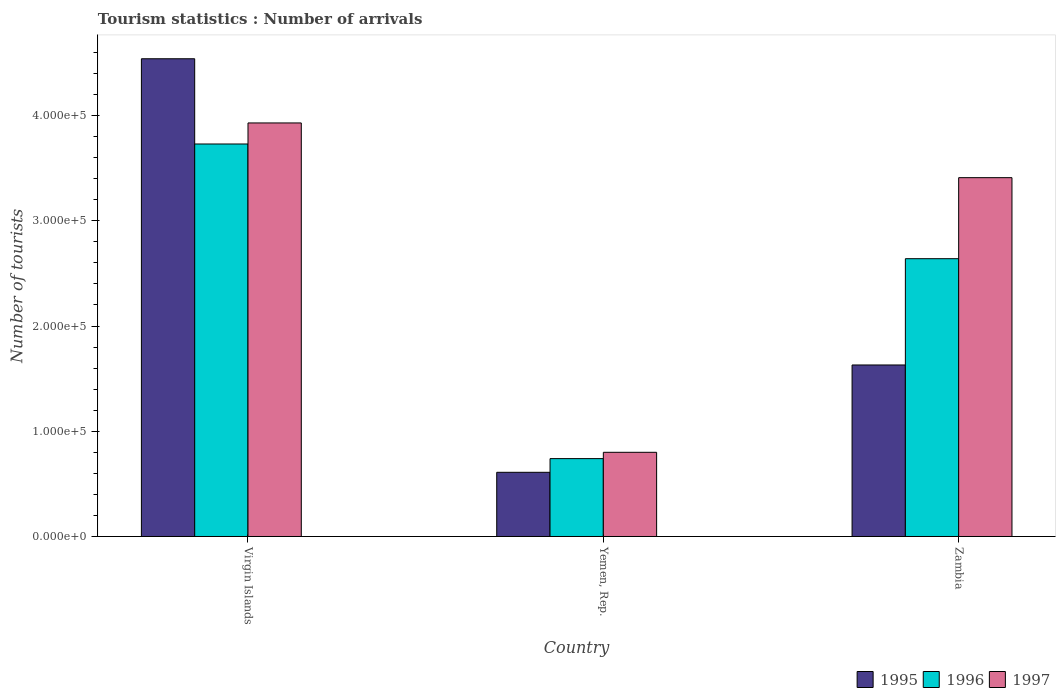How many groups of bars are there?
Offer a very short reply. 3. Are the number of bars per tick equal to the number of legend labels?
Provide a succinct answer. Yes. How many bars are there on the 3rd tick from the left?
Provide a short and direct response. 3. How many bars are there on the 3rd tick from the right?
Offer a very short reply. 3. What is the label of the 2nd group of bars from the left?
Your response must be concise. Yemen, Rep. What is the number of tourist arrivals in 1995 in Virgin Islands?
Ensure brevity in your answer.  4.54e+05. Across all countries, what is the maximum number of tourist arrivals in 1997?
Provide a short and direct response. 3.93e+05. Across all countries, what is the minimum number of tourist arrivals in 1995?
Your answer should be very brief. 6.10e+04. In which country was the number of tourist arrivals in 1996 maximum?
Your answer should be very brief. Virgin Islands. In which country was the number of tourist arrivals in 1995 minimum?
Provide a succinct answer. Yemen, Rep. What is the total number of tourist arrivals in 1995 in the graph?
Make the answer very short. 6.78e+05. What is the difference between the number of tourist arrivals in 1996 in Yemen, Rep. and that in Zambia?
Your answer should be very brief. -1.90e+05. What is the average number of tourist arrivals in 1996 per country?
Make the answer very short. 2.37e+05. What is the difference between the number of tourist arrivals of/in 1995 and number of tourist arrivals of/in 1996 in Yemen, Rep.?
Offer a very short reply. -1.30e+04. In how many countries, is the number of tourist arrivals in 1996 greater than 200000?
Your answer should be compact. 2. What is the ratio of the number of tourist arrivals in 1996 in Yemen, Rep. to that in Zambia?
Offer a very short reply. 0.28. What is the difference between the highest and the second highest number of tourist arrivals in 1996?
Ensure brevity in your answer.  2.99e+05. What is the difference between the highest and the lowest number of tourist arrivals in 1997?
Provide a succinct answer. 3.13e+05. Is the sum of the number of tourist arrivals in 1995 in Yemen, Rep. and Zambia greater than the maximum number of tourist arrivals in 1996 across all countries?
Provide a succinct answer. No. What does the 1st bar from the left in Yemen, Rep. represents?
Your answer should be compact. 1995. How many bars are there?
Provide a short and direct response. 9. What is the difference between two consecutive major ticks on the Y-axis?
Give a very brief answer. 1.00e+05. Where does the legend appear in the graph?
Your answer should be compact. Bottom right. How many legend labels are there?
Offer a terse response. 3. How are the legend labels stacked?
Your answer should be very brief. Horizontal. What is the title of the graph?
Your response must be concise. Tourism statistics : Number of arrivals. Does "1981" appear as one of the legend labels in the graph?
Provide a succinct answer. No. What is the label or title of the X-axis?
Provide a succinct answer. Country. What is the label or title of the Y-axis?
Keep it short and to the point. Number of tourists. What is the Number of tourists of 1995 in Virgin Islands?
Provide a succinct answer. 4.54e+05. What is the Number of tourists of 1996 in Virgin Islands?
Make the answer very short. 3.73e+05. What is the Number of tourists of 1997 in Virgin Islands?
Provide a short and direct response. 3.93e+05. What is the Number of tourists in 1995 in Yemen, Rep.?
Provide a short and direct response. 6.10e+04. What is the Number of tourists in 1996 in Yemen, Rep.?
Offer a terse response. 7.40e+04. What is the Number of tourists in 1995 in Zambia?
Make the answer very short. 1.63e+05. What is the Number of tourists in 1996 in Zambia?
Give a very brief answer. 2.64e+05. What is the Number of tourists of 1997 in Zambia?
Make the answer very short. 3.41e+05. Across all countries, what is the maximum Number of tourists in 1995?
Make the answer very short. 4.54e+05. Across all countries, what is the maximum Number of tourists of 1996?
Make the answer very short. 3.73e+05. Across all countries, what is the maximum Number of tourists of 1997?
Give a very brief answer. 3.93e+05. Across all countries, what is the minimum Number of tourists of 1995?
Offer a very short reply. 6.10e+04. Across all countries, what is the minimum Number of tourists of 1996?
Make the answer very short. 7.40e+04. Across all countries, what is the minimum Number of tourists in 1997?
Give a very brief answer. 8.00e+04. What is the total Number of tourists in 1995 in the graph?
Your answer should be compact. 6.78e+05. What is the total Number of tourists of 1996 in the graph?
Offer a very short reply. 7.11e+05. What is the total Number of tourists of 1997 in the graph?
Your response must be concise. 8.14e+05. What is the difference between the Number of tourists of 1995 in Virgin Islands and that in Yemen, Rep.?
Provide a short and direct response. 3.93e+05. What is the difference between the Number of tourists of 1996 in Virgin Islands and that in Yemen, Rep.?
Offer a terse response. 2.99e+05. What is the difference between the Number of tourists of 1997 in Virgin Islands and that in Yemen, Rep.?
Give a very brief answer. 3.13e+05. What is the difference between the Number of tourists in 1995 in Virgin Islands and that in Zambia?
Keep it short and to the point. 2.91e+05. What is the difference between the Number of tourists in 1996 in Virgin Islands and that in Zambia?
Your answer should be compact. 1.09e+05. What is the difference between the Number of tourists in 1997 in Virgin Islands and that in Zambia?
Offer a very short reply. 5.20e+04. What is the difference between the Number of tourists of 1995 in Yemen, Rep. and that in Zambia?
Make the answer very short. -1.02e+05. What is the difference between the Number of tourists of 1996 in Yemen, Rep. and that in Zambia?
Offer a very short reply. -1.90e+05. What is the difference between the Number of tourists of 1997 in Yemen, Rep. and that in Zambia?
Ensure brevity in your answer.  -2.61e+05. What is the difference between the Number of tourists of 1995 in Virgin Islands and the Number of tourists of 1997 in Yemen, Rep.?
Your answer should be very brief. 3.74e+05. What is the difference between the Number of tourists of 1996 in Virgin Islands and the Number of tourists of 1997 in Yemen, Rep.?
Your answer should be very brief. 2.93e+05. What is the difference between the Number of tourists in 1995 in Virgin Islands and the Number of tourists in 1997 in Zambia?
Your answer should be compact. 1.13e+05. What is the difference between the Number of tourists in 1996 in Virgin Islands and the Number of tourists in 1997 in Zambia?
Provide a short and direct response. 3.20e+04. What is the difference between the Number of tourists of 1995 in Yemen, Rep. and the Number of tourists of 1996 in Zambia?
Offer a very short reply. -2.03e+05. What is the difference between the Number of tourists of 1995 in Yemen, Rep. and the Number of tourists of 1997 in Zambia?
Offer a very short reply. -2.80e+05. What is the difference between the Number of tourists of 1996 in Yemen, Rep. and the Number of tourists of 1997 in Zambia?
Provide a short and direct response. -2.67e+05. What is the average Number of tourists of 1995 per country?
Keep it short and to the point. 2.26e+05. What is the average Number of tourists of 1996 per country?
Offer a terse response. 2.37e+05. What is the average Number of tourists of 1997 per country?
Offer a terse response. 2.71e+05. What is the difference between the Number of tourists of 1995 and Number of tourists of 1996 in Virgin Islands?
Your answer should be very brief. 8.10e+04. What is the difference between the Number of tourists of 1995 and Number of tourists of 1997 in Virgin Islands?
Your response must be concise. 6.10e+04. What is the difference between the Number of tourists in 1996 and Number of tourists in 1997 in Virgin Islands?
Your response must be concise. -2.00e+04. What is the difference between the Number of tourists in 1995 and Number of tourists in 1996 in Yemen, Rep.?
Offer a very short reply. -1.30e+04. What is the difference between the Number of tourists of 1995 and Number of tourists of 1997 in Yemen, Rep.?
Make the answer very short. -1.90e+04. What is the difference between the Number of tourists in 1996 and Number of tourists in 1997 in Yemen, Rep.?
Provide a short and direct response. -6000. What is the difference between the Number of tourists of 1995 and Number of tourists of 1996 in Zambia?
Your answer should be compact. -1.01e+05. What is the difference between the Number of tourists of 1995 and Number of tourists of 1997 in Zambia?
Ensure brevity in your answer.  -1.78e+05. What is the difference between the Number of tourists of 1996 and Number of tourists of 1997 in Zambia?
Offer a terse response. -7.70e+04. What is the ratio of the Number of tourists in 1995 in Virgin Islands to that in Yemen, Rep.?
Keep it short and to the point. 7.44. What is the ratio of the Number of tourists of 1996 in Virgin Islands to that in Yemen, Rep.?
Your answer should be very brief. 5.04. What is the ratio of the Number of tourists of 1997 in Virgin Islands to that in Yemen, Rep.?
Ensure brevity in your answer.  4.91. What is the ratio of the Number of tourists of 1995 in Virgin Islands to that in Zambia?
Offer a terse response. 2.79. What is the ratio of the Number of tourists in 1996 in Virgin Islands to that in Zambia?
Your response must be concise. 1.41. What is the ratio of the Number of tourists of 1997 in Virgin Islands to that in Zambia?
Offer a very short reply. 1.15. What is the ratio of the Number of tourists of 1995 in Yemen, Rep. to that in Zambia?
Keep it short and to the point. 0.37. What is the ratio of the Number of tourists of 1996 in Yemen, Rep. to that in Zambia?
Your answer should be compact. 0.28. What is the ratio of the Number of tourists of 1997 in Yemen, Rep. to that in Zambia?
Offer a very short reply. 0.23. What is the difference between the highest and the second highest Number of tourists in 1995?
Make the answer very short. 2.91e+05. What is the difference between the highest and the second highest Number of tourists of 1996?
Give a very brief answer. 1.09e+05. What is the difference between the highest and the second highest Number of tourists of 1997?
Offer a terse response. 5.20e+04. What is the difference between the highest and the lowest Number of tourists in 1995?
Your answer should be compact. 3.93e+05. What is the difference between the highest and the lowest Number of tourists in 1996?
Provide a succinct answer. 2.99e+05. What is the difference between the highest and the lowest Number of tourists of 1997?
Make the answer very short. 3.13e+05. 